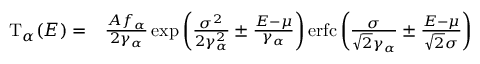Convert formula to latex. <formula><loc_0><loc_0><loc_500><loc_500>\begin{array} { r l } { T _ { \alpha } ( E ) = } & { \frac { A f _ { \alpha } } { 2 \gamma _ { \alpha } } \exp \left ( \frac { \sigma ^ { 2 } } { 2 \gamma _ { \alpha } ^ { 2 } } \pm \frac { E - \mu } { \gamma _ { \alpha } } \right ) e r f c \left ( \frac { \sigma } { \sqrt { 2 } \gamma _ { \alpha } } \pm \frac { E - \mu } { \sqrt { 2 } \sigma } \right ) } \end{array}</formula> 